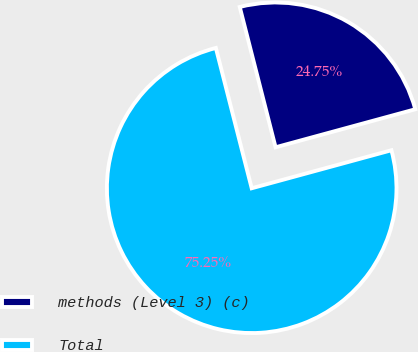<chart> <loc_0><loc_0><loc_500><loc_500><pie_chart><fcel>methods (Level 3) (c)<fcel>Total<nl><fcel>24.75%<fcel>75.25%<nl></chart> 